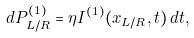<formula> <loc_0><loc_0><loc_500><loc_500>d P ^ { ( 1 ) } _ { L / R } = \eta I ^ { ( 1 ) } ( x _ { L / R } , t ) \, d t ,</formula> 